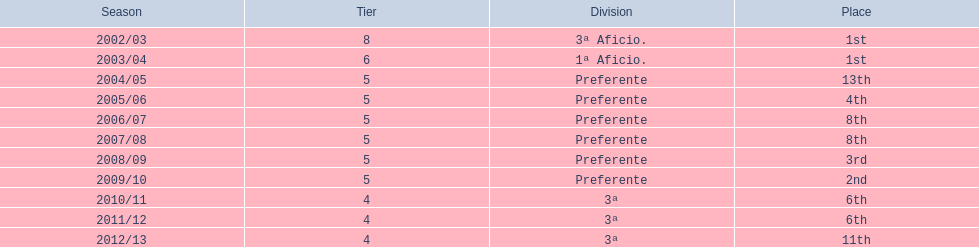How many instances did internacional de madrid cf achieve 6th place? 6th, 6th. What is the premier season when the team ranked 6th? 2010/11. In which season after the premier did they attain 6th again? 2011/12. 